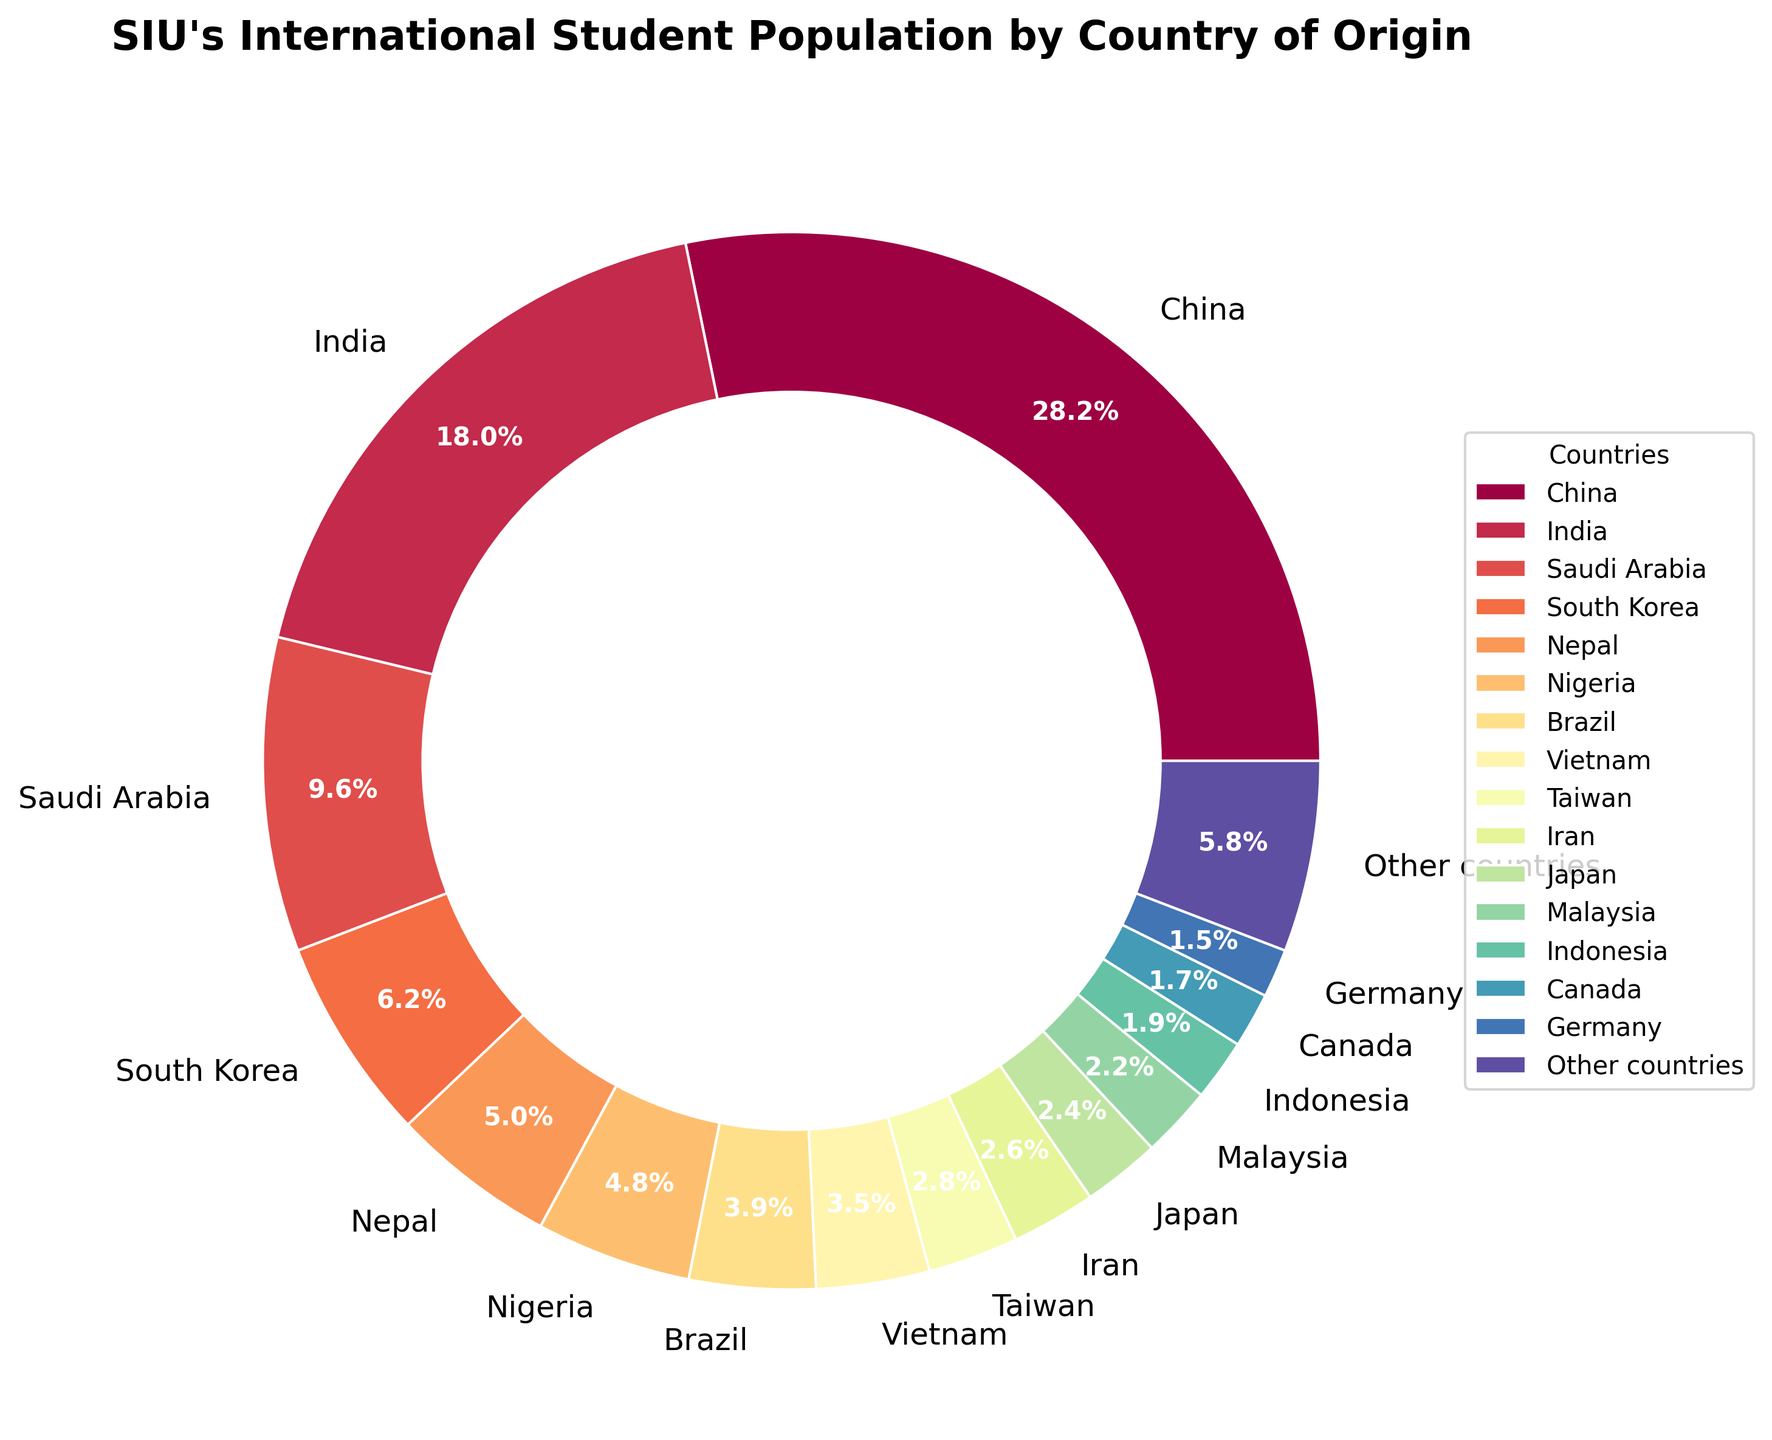What are the top three countries with the highest percentage of international students at SIU? The top three countries can be identified by looking at the largest segments in the pie chart. The largest percentage is for China (28.5%), followed by India (18.2%), and Saudi Arabia (9.7%).
Answer: China, India, Saudi Arabia What is the combined percentage of students from China, India, and Saudi Arabia? To find the combined percentage, simply sum the percentages of the three countries. Adding 28.5% (China) + 18.2% (India) + 9.7% (Saudi Arabia) gives a total of 56.4%.
Answer: 56.4% How does the percentage of students from Nigeria compare to that from Brazil? By comparing the segments of Nigeria and Brazil, we see that Nigeria has 4.8%, and Brazil has 3.9%. Nigeria has a slightly higher percentage than Brazil.
Answer: Nigeria has a higher percentage than Brazil Look at the segments for Nepal and Vietnam. Which country has a higher percentage, and by how much? Nepal has 5.1%, and Vietnam has 3.5%. By subtracting Vietnam's percentage from Nepal's, 5.1% - 3.5% equals 1.6%. Nepal has a higher percentage by 1.6%.
Answer: Nepal by 1.6% Which country contributes a larger percentage of international students: Iran or Japan? By examining their segments, we see that Iran has 2.6% and Japan has 2.4%. Therefore, Iran contributes a larger percentage than Japan.
Answer: Iran What visual difference is observed between the wedges representing India and South Korea? The visual difference lies in the size of the wedges. The wedge for India (18.2%) is significantly larger than the wedge for South Korea (6.3%).
Answer: India's wedge is larger than South Korea’s What is the total percentage contributed by countries other than China, India, and Saudi Arabia? Total percentage excluding China (28.5%), India (18.2%), and Saudi Arabia (9.7%) can be found by subtracting their sum from 100%. Total = 28.5% + 18.2% + 9.7% = 56.4%. Therefore, other countries = 100% - 56.4% = 43.6%.
Answer: 43.6% Is the percentage of international students from Canada higher or lower than that from Indonesia? Canada has 1.7%, and Indonesia has 1.9%. Observing the pie chart, we see that Indonesia's percentage is slightly higher than Canada's.
Answer: Lower Which segment is visually the smallest, and what is its percentage? By observing the smallest segment in the pie chart, we find that Germany has the smallest percentage at 1.5%.
Answer: Germany, 1.5% How many countries have a percentage of international students higher than 5%? By examining the segmentation, we identify that four countries have a percentage higher than 5%: China (28.5%), India (18.2%), Saudi Arabia (9.7%), and Nepal (5.1%).
Answer: Four 